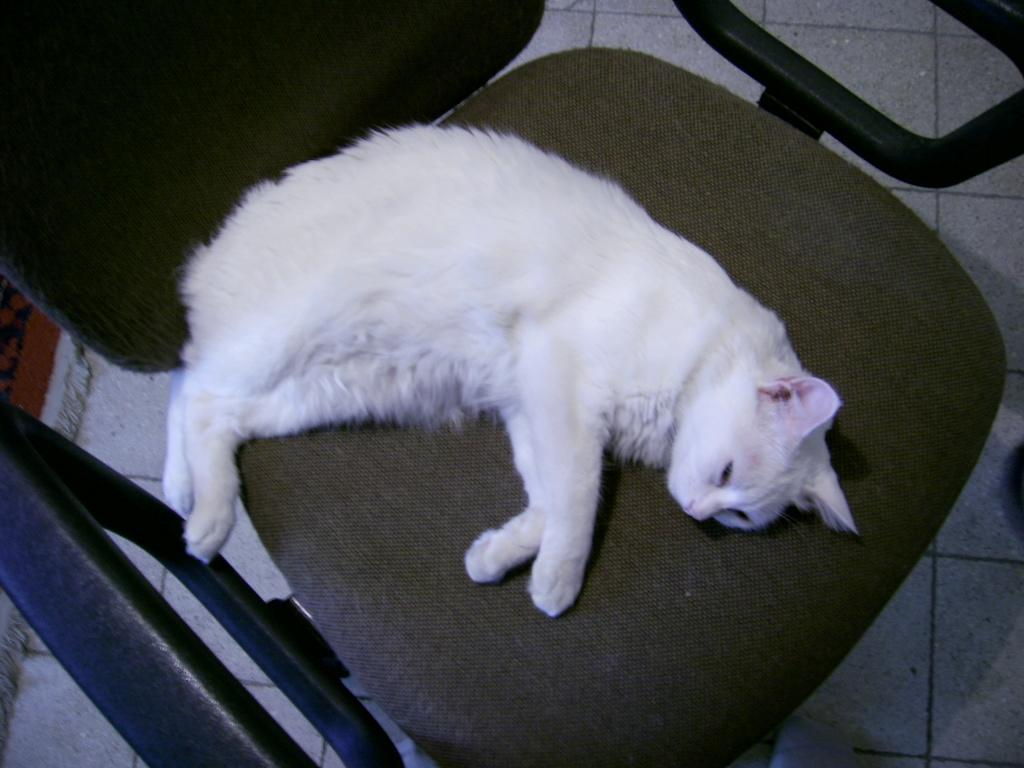What type of animal is in the image? There is a cat in the image. What is the cat doing in the image? The cat is laying on a chair. What color is the cat in the image? The cat is white in color. What type of business is the cat running in the image? There is no indication of a business in the image; it simply shows a white cat laying on a chair. 